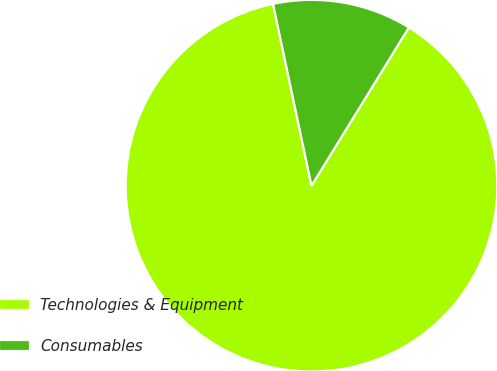Convert chart to OTSL. <chart><loc_0><loc_0><loc_500><loc_500><pie_chart><fcel>Technologies & Equipment<fcel>Consumables<nl><fcel>87.9%<fcel>12.1%<nl></chart> 